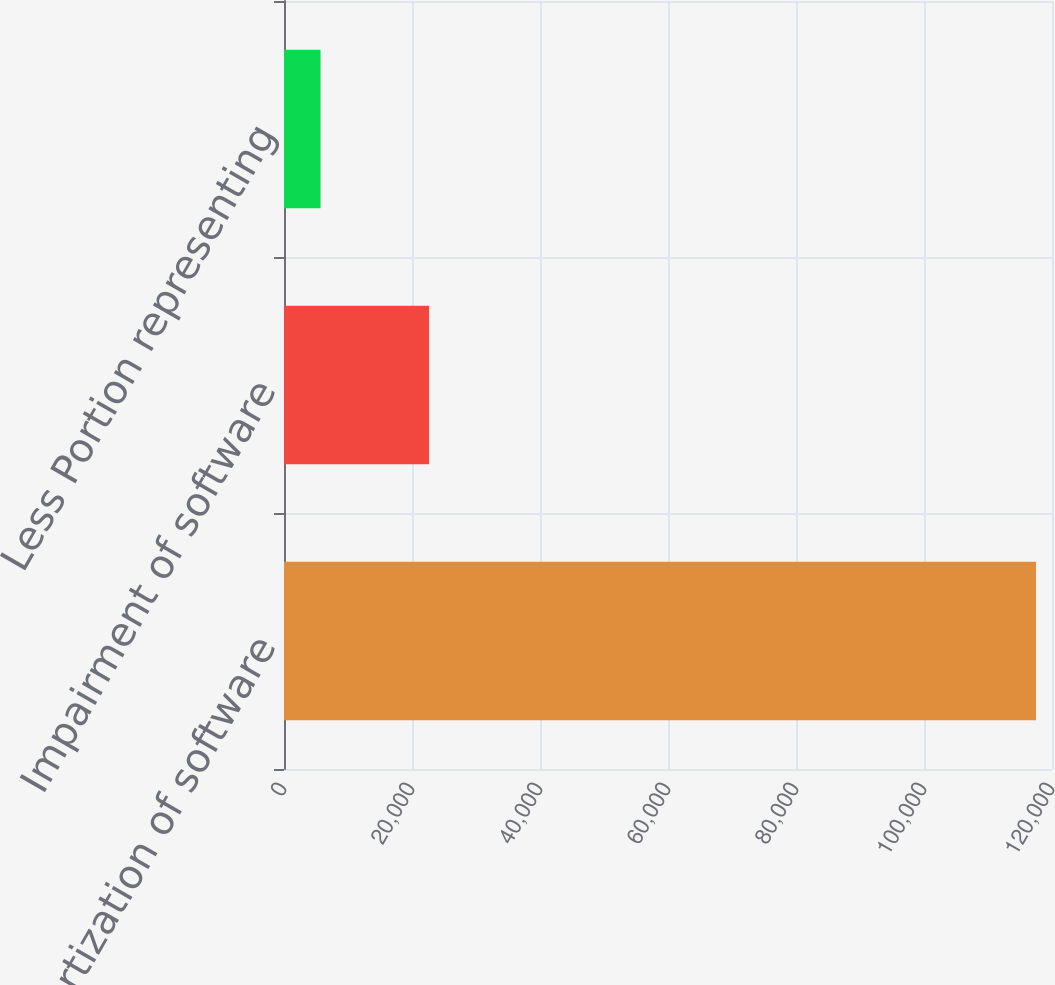<chart> <loc_0><loc_0><loc_500><loc_500><bar_chart><fcel>Amortization of software<fcel>Impairment of software<fcel>Less Portion representing<nl><fcel>117506<fcel>22671<fcel>5705<nl></chart> 